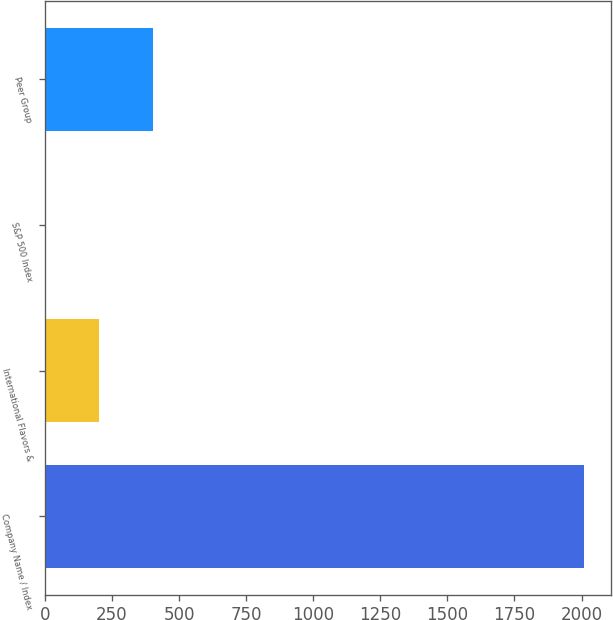Convert chart. <chart><loc_0><loc_0><loc_500><loc_500><bar_chart><fcel>Company Name / Index<fcel>International Flavors &<fcel>S&P 500 Index<fcel>Peer Group<nl><fcel>2011<fcel>203<fcel>2.11<fcel>403.89<nl></chart> 